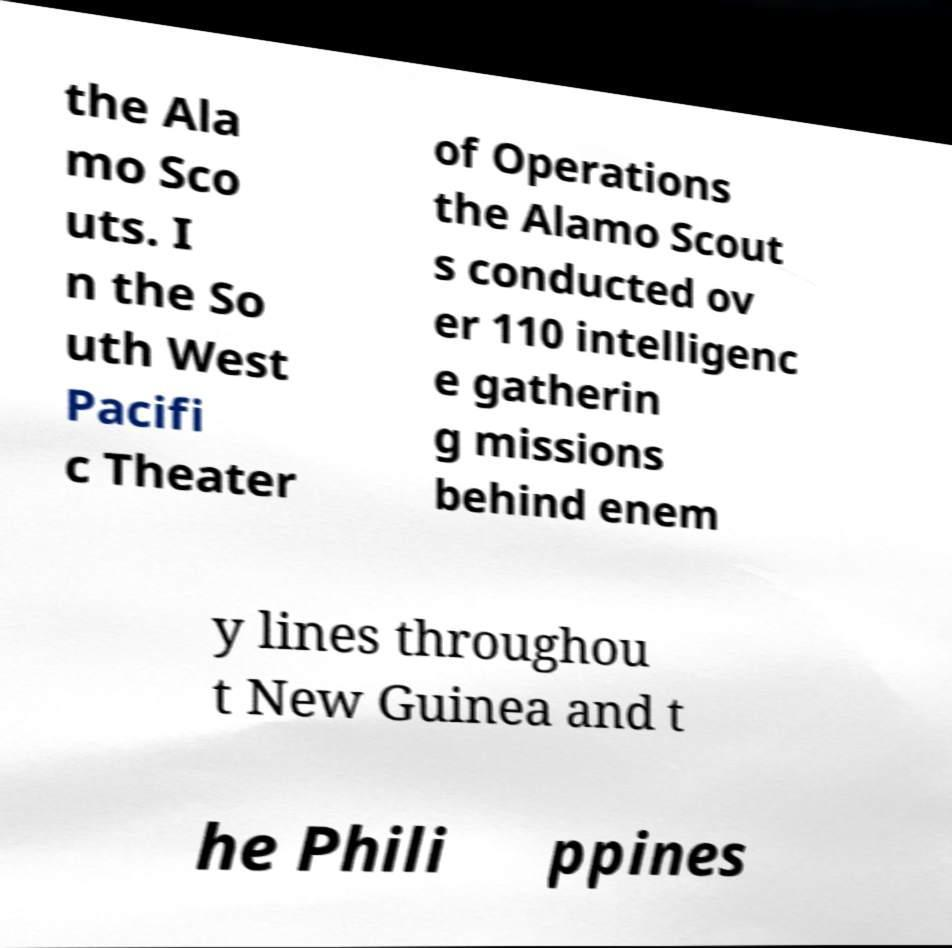What messages or text are displayed in this image? I need them in a readable, typed format. the Ala mo Sco uts. I n the So uth West Pacifi c Theater of Operations the Alamo Scout s conducted ov er 110 intelligenc e gatherin g missions behind enem y lines throughou t New Guinea and t he Phili ppines 